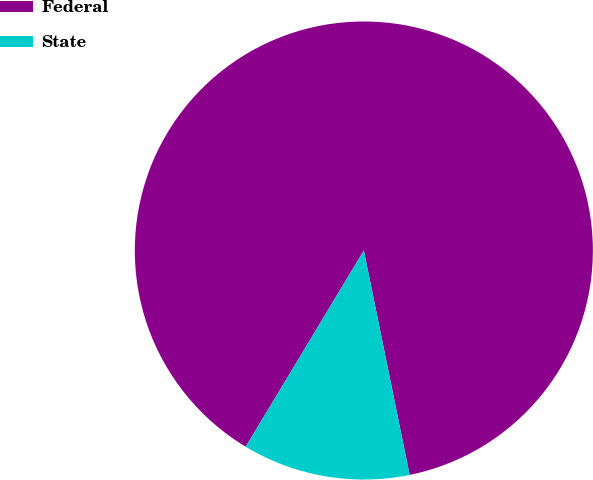Convert chart to OTSL. <chart><loc_0><loc_0><loc_500><loc_500><pie_chart><fcel>Federal<fcel>State<nl><fcel>88.17%<fcel>11.83%<nl></chart> 